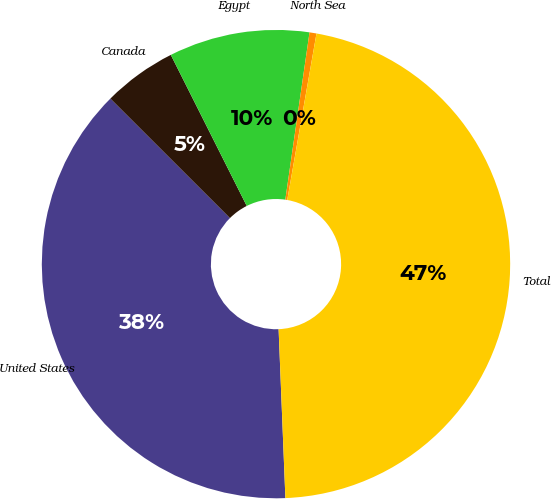Convert chart. <chart><loc_0><loc_0><loc_500><loc_500><pie_chart><fcel>United States<fcel>Canada<fcel>Egypt<fcel>North Sea<fcel>Total<nl><fcel>38.13%<fcel>5.09%<fcel>9.7%<fcel>0.48%<fcel>46.59%<nl></chart> 